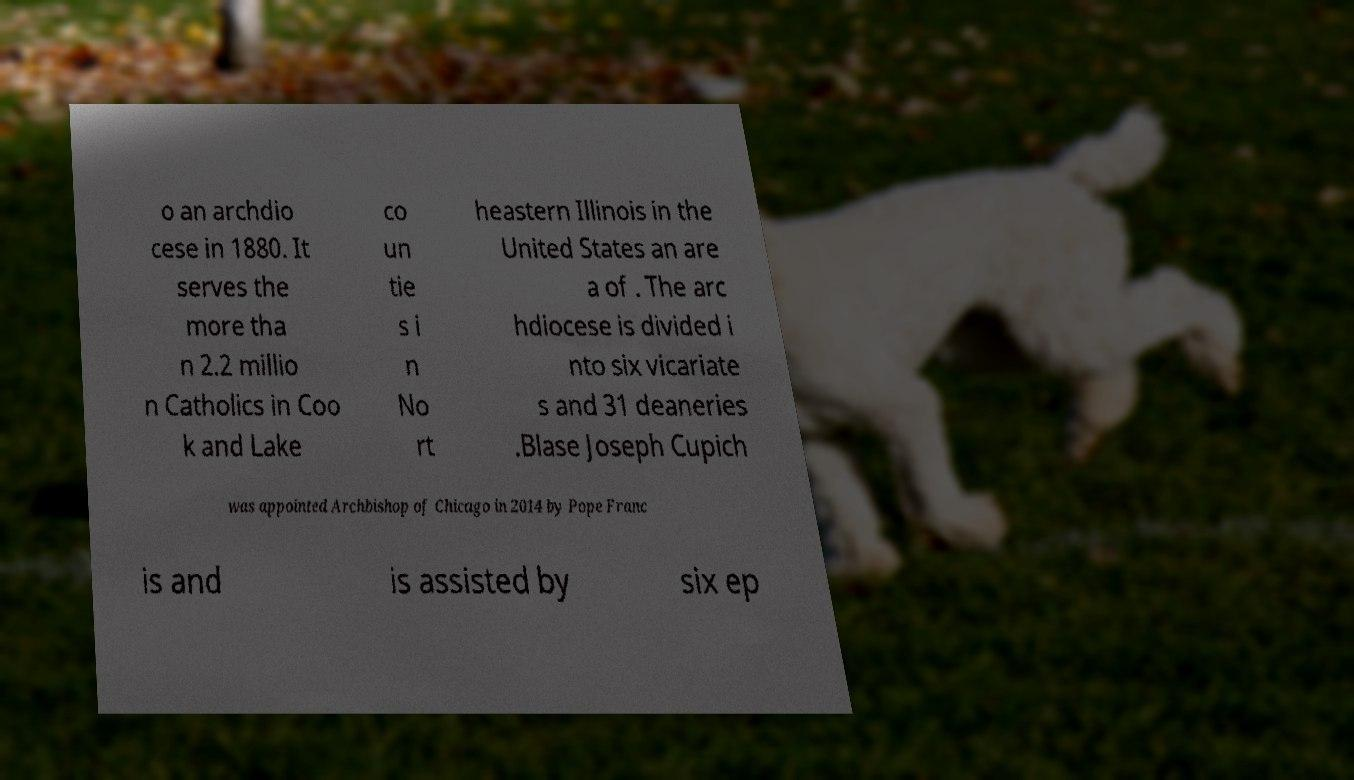Please read and relay the text visible in this image. What does it say? o an archdio cese in 1880. It serves the more tha n 2.2 millio n Catholics in Coo k and Lake co un tie s i n No rt heastern Illinois in the United States an are a of . The arc hdiocese is divided i nto six vicariate s and 31 deaneries .Blase Joseph Cupich was appointed Archbishop of Chicago in 2014 by Pope Franc is and is assisted by six ep 